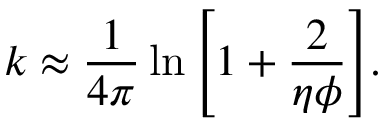Convert formula to latex. <formula><loc_0><loc_0><loc_500><loc_500>k \approx \frac { 1 } { 4 \pi } \ln { \left [ 1 + \frac { 2 } { \eta \phi } \right ] } .</formula> 